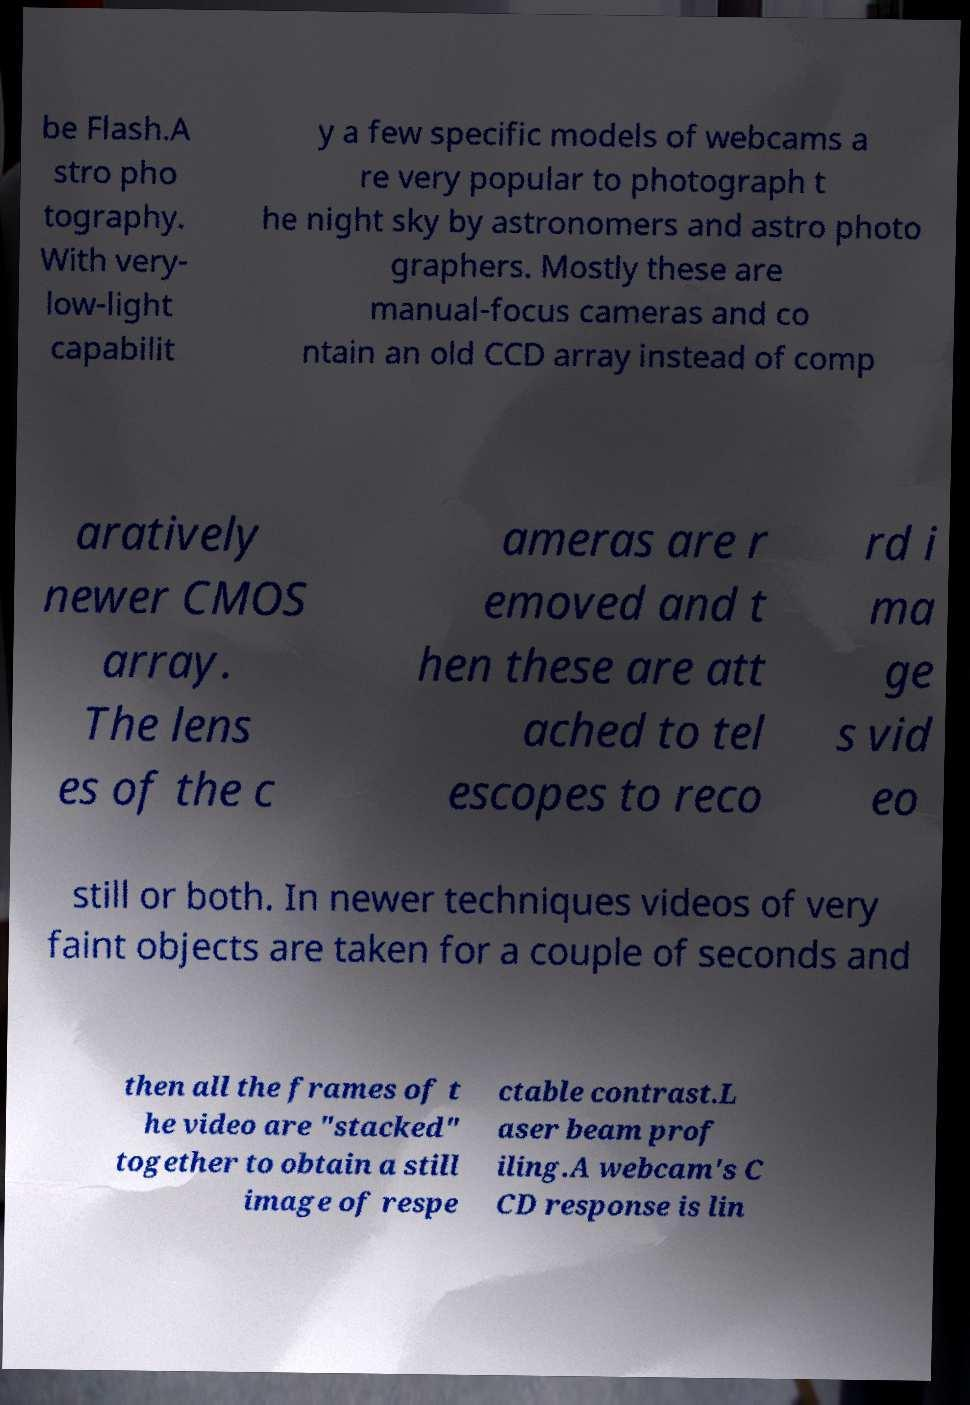Could you assist in decoding the text presented in this image and type it out clearly? be Flash.A stro pho tography. With very- low-light capabilit y a few specific models of webcams a re very popular to photograph t he night sky by astronomers and astro photo graphers. Mostly these are manual-focus cameras and co ntain an old CCD array instead of comp aratively newer CMOS array. The lens es of the c ameras are r emoved and t hen these are att ached to tel escopes to reco rd i ma ge s vid eo still or both. In newer techniques videos of very faint objects are taken for a couple of seconds and then all the frames of t he video are "stacked" together to obtain a still image of respe ctable contrast.L aser beam prof iling.A webcam's C CD response is lin 